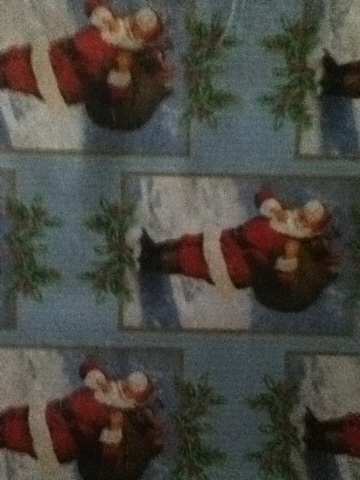Can you describe the main theme of this wrapping paper? The main theme of this wrapping paper is Christmas. It prominently features images of Santa Claus carrying gifts, set against a wintery background, making it a festive choice for the holiday season. 